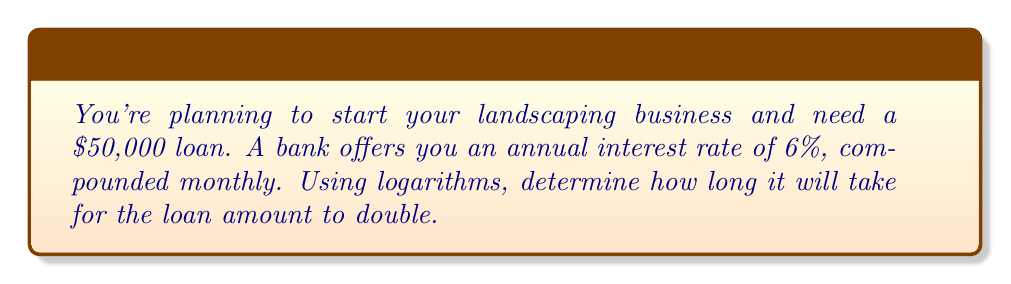Can you solve this math problem? Let's approach this step-by-step using the compound interest formula and logarithms:

1) The compound interest formula is:
   $$A = P(1 + \frac{r}{n})^{nt}$$
   Where:
   $A$ = final amount
   $P$ = principal (initial loan amount)
   $r$ = annual interest rate (as a decimal)
   $n$ = number of times interest is compounded per year
   $t$ = time in years

2) We want to find when the amount doubles, so:
   $$2P = P(1 + \frac{r}{n})^{nt}$$

3) Divide both sides by $P$:
   $$2 = (1 + \frac{r}{n})^{nt}$$

4) Take the natural log of both sides:
   $$\ln(2) = nt \ln(1 + \frac{r}{n})$$

5) Solve for $t$:
   $$t = \frac{\ln(2)}{n \ln(1 + \frac{r}{n})}$$

6) Now, let's plug in our values:
   $r = 0.06$ (6% as a decimal)
   $n = 12$ (compounded monthly)

   $$t = \frac{\ln(2)}{12 \ln(1 + \frac{0.06}{12})}$$

7) Calculate:
   $$t = \frac{0.6931471806}{12 \ln(1.005)} \approx 11.90$$
Answer: 11.90 years 